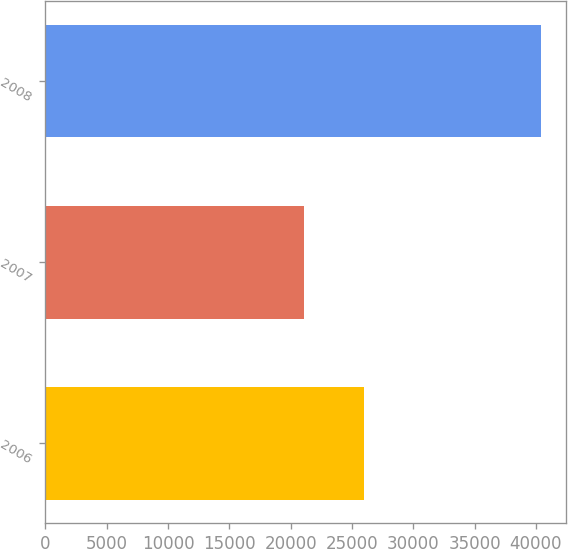Convert chart to OTSL. <chart><loc_0><loc_0><loc_500><loc_500><bar_chart><fcel>2006<fcel>2007<fcel>2008<nl><fcel>25944<fcel>21069<fcel>40452<nl></chart> 